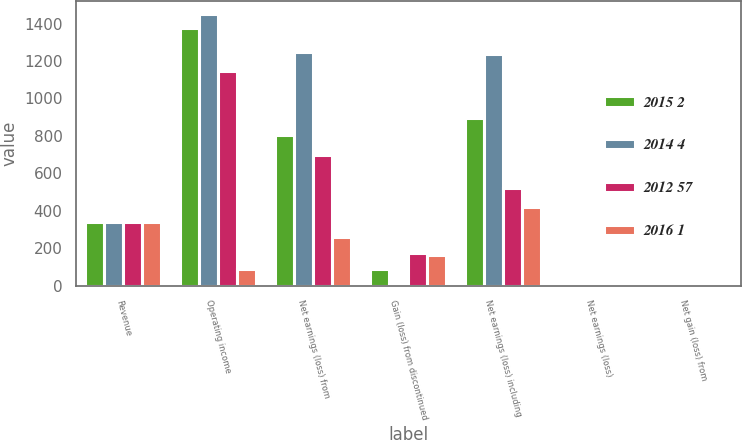<chart> <loc_0><loc_0><loc_500><loc_500><stacked_bar_chart><ecel><fcel>Revenue<fcel>Operating income<fcel>Net earnings (loss) from<fcel>Gain (loss) from discontinued<fcel>Net earnings (loss) including<fcel>Net earnings (loss)<fcel>Net gain (loss) from<nl><fcel>2015 2<fcel>339.5<fcel>1375<fcel>807<fcel>90<fcel>897<fcel>2.56<fcel>0.26<nl><fcel>2014 4<fcel>339.5<fcel>1450<fcel>1246<fcel>11<fcel>1235<fcel>3.49<fcel>0.04<nl><fcel>2012 57<fcel>339.5<fcel>1144<fcel>695<fcel>172<fcel>523<fcel>1.53<fcel>0.47<nl><fcel>2016 1<fcel>339.5<fcel>90<fcel>259<fcel>161<fcel>420<fcel>1.3<fcel>0.54<nl></chart> 